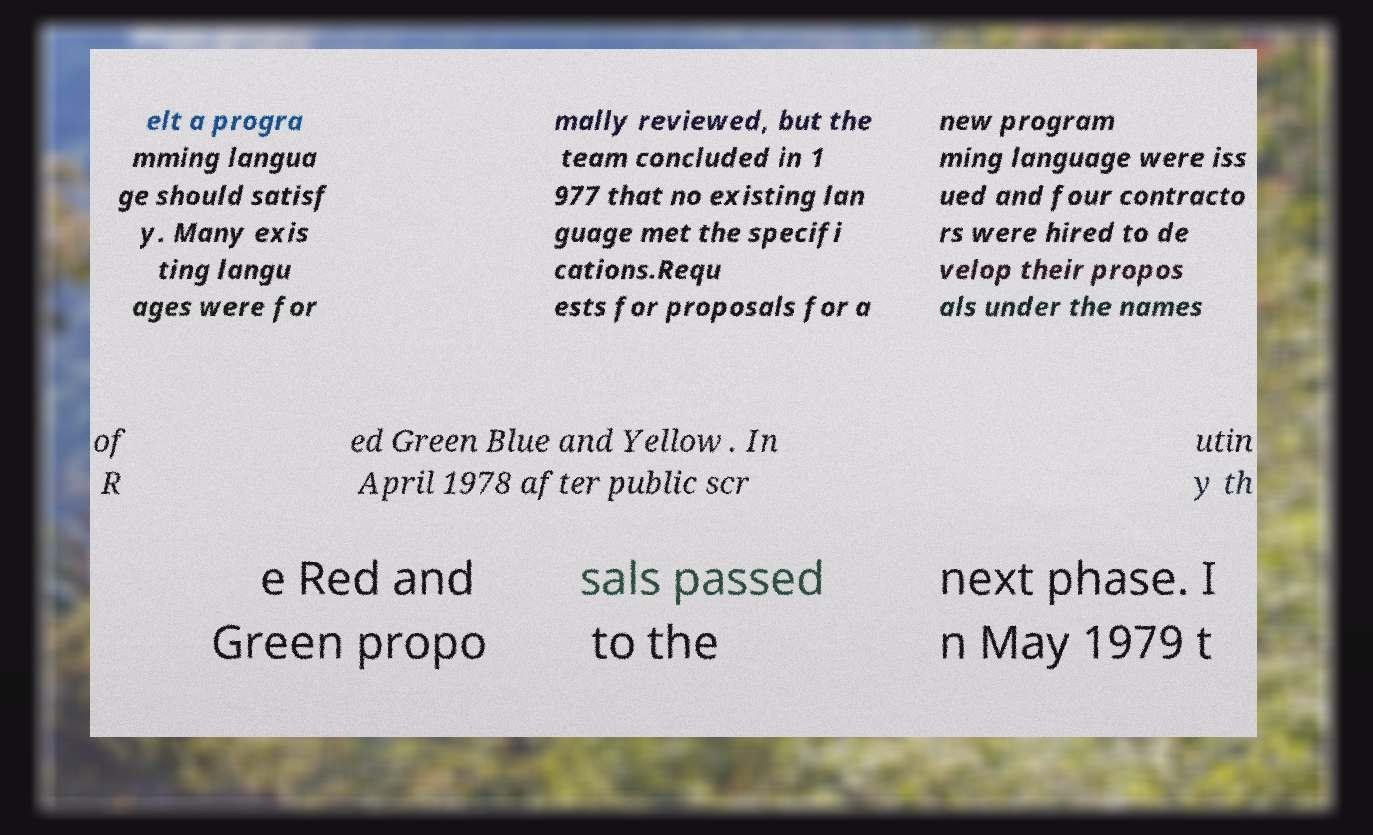Can you accurately transcribe the text from the provided image for me? elt a progra mming langua ge should satisf y. Many exis ting langu ages were for mally reviewed, but the team concluded in 1 977 that no existing lan guage met the specifi cations.Requ ests for proposals for a new program ming language were iss ued and four contracto rs were hired to de velop their propos als under the names of R ed Green Blue and Yellow . In April 1978 after public scr utin y th e Red and Green propo sals passed to the next phase. I n May 1979 t 